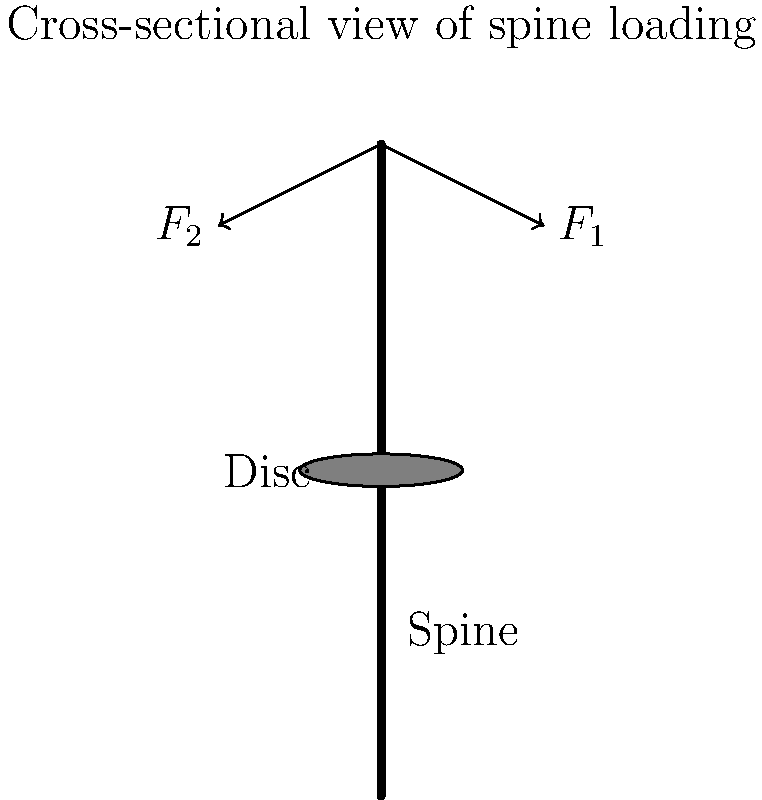When loading suitcases into an aircraft's cargo hold, the spine experiences compressive forces. In the diagram, two forces $F_1$ and $F_2$ act on the spine at an angle of 30° from the vertical. If each force has a magnitude of 200 N, what is the total compressive force experienced by the intervertebral disc? To solve this problem, we'll follow these steps:

1. Identify the vertical components of the forces:
   The vertical component contributes to the compressive force on the spine.

2. Calculate the vertical component of each force:
   Using trigonometry, we can find the vertical component.
   Vertical component = $F \cos(\theta)$
   Where $F$ is the force magnitude and $\theta$ is the angle from vertical.

3. For each force:
   Vertical component = $200 \text{ N} \times \cos(30°)$
   $= 200 \text{ N} \times \frac{\sqrt{3}}{2}$
   $\approx 173.2 \text{ N}$

4. Sum the vertical components:
   Total compressive force = Vertical component of $F_1$ + Vertical component of $F_2$
   $= 173.2 \text{ N} + 173.2 \text{ N}$
   $= 346.4 \text{ N}$

Therefore, the total compressive force experienced by the intervertebral disc is approximately 346.4 N.
Answer: 346.4 N 